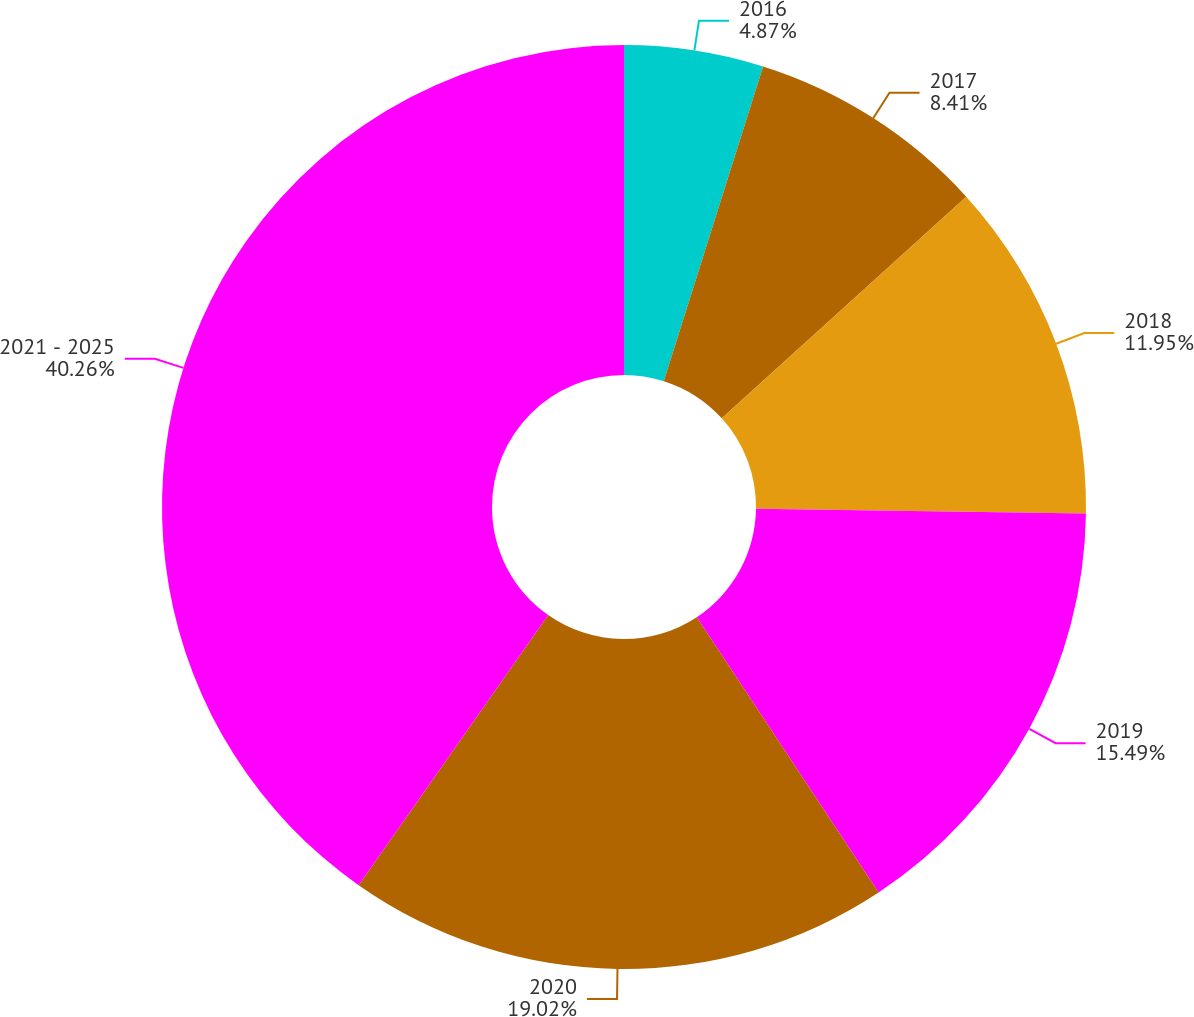<chart> <loc_0><loc_0><loc_500><loc_500><pie_chart><fcel>2016<fcel>2017<fcel>2018<fcel>2019<fcel>2020<fcel>2021 - 2025<nl><fcel>4.87%<fcel>8.41%<fcel>11.95%<fcel>15.49%<fcel>19.03%<fcel>40.27%<nl></chart> 